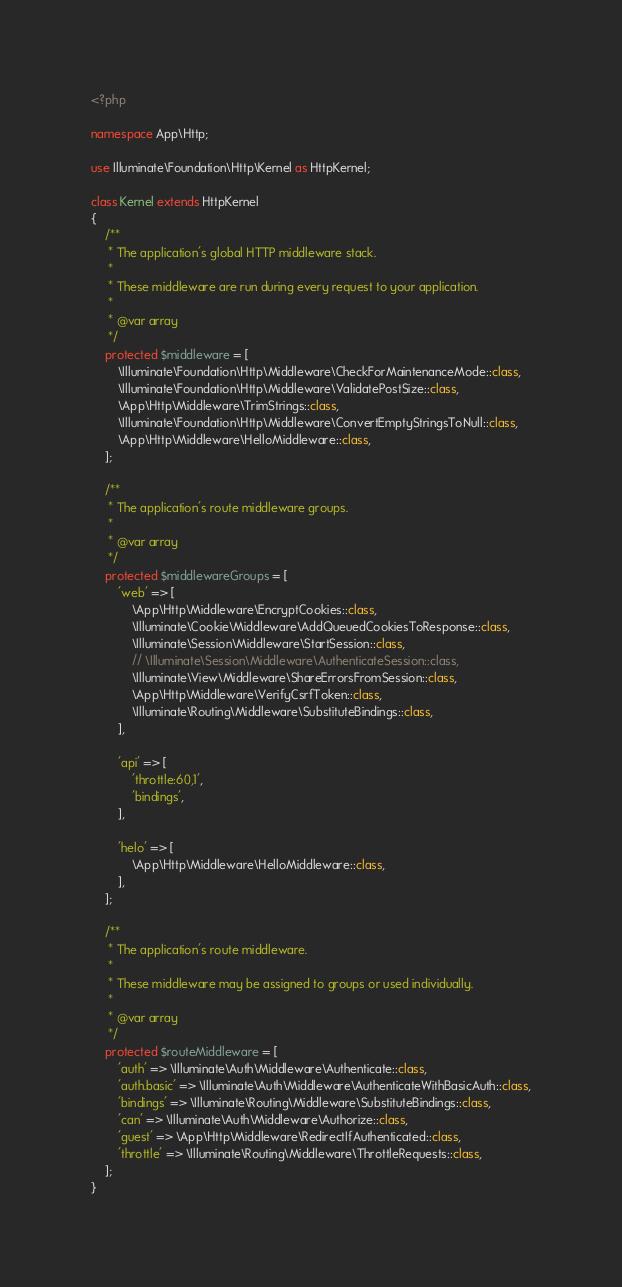<code> <loc_0><loc_0><loc_500><loc_500><_PHP_><?php

namespace App\Http;

use Illuminate\Foundation\Http\Kernel as HttpKernel;

class Kernel extends HttpKernel
{
    /**
     * The application's global HTTP middleware stack.
     *
     * These middleware are run during every request to your application.
     *
     * @var array
     */
    protected $middleware = [
        \Illuminate\Foundation\Http\Middleware\CheckForMaintenanceMode::class,
        \Illuminate\Foundation\Http\Middleware\ValidatePostSize::class,
        \App\Http\Middleware\TrimStrings::class,
        \Illuminate\Foundation\Http\Middleware\ConvertEmptyStringsToNull::class,
        \App\Http\Middleware\HelloMiddleware::class,
    ];

    /**
     * The application's route middleware groups.
     *
     * @var array
     */
    protected $middlewareGroups = [
        'web' => [
            \App\Http\Middleware\EncryptCookies::class,
            \Illuminate\Cookie\Middleware\AddQueuedCookiesToResponse::class,
            \Illuminate\Session\Middleware\StartSession::class,
            // \Illuminate\Session\Middleware\AuthenticateSession::class,
            \Illuminate\View\Middleware\ShareErrorsFromSession::class,
            \App\Http\Middleware\VerifyCsrfToken::class,
            \Illuminate\Routing\Middleware\SubstituteBindings::class,
        ],

        'api' => [
            'throttle:60,1',
            'bindings',
        ],

        'helo' => [
            \App\Http\Middleware\HelloMiddleware::class,
        ],
    ];

    /**
     * The application's route middleware.
     *
     * These middleware may be assigned to groups or used individually.
     *
     * @var array
     */
    protected $routeMiddleware = [
        'auth' => \Illuminate\Auth\Middleware\Authenticate::class,
        'auth.basic' => \Illuminate\Auth\Middleware\AuthenticateWithBasicAuth::class,
        'bindings' => \Illuminate\Routing\Middleware\SubstituteBindings::class,
        'can' => \Illuminate\Auth\Middleware\Authorize::class,
        'guest' => \App\Http\Middleware\RedirectIfAuthenticated::class,
        'throttle' => \Illuminate\Routing\Middleware\ThrottleRequests::class,
    ];
}
</code> 